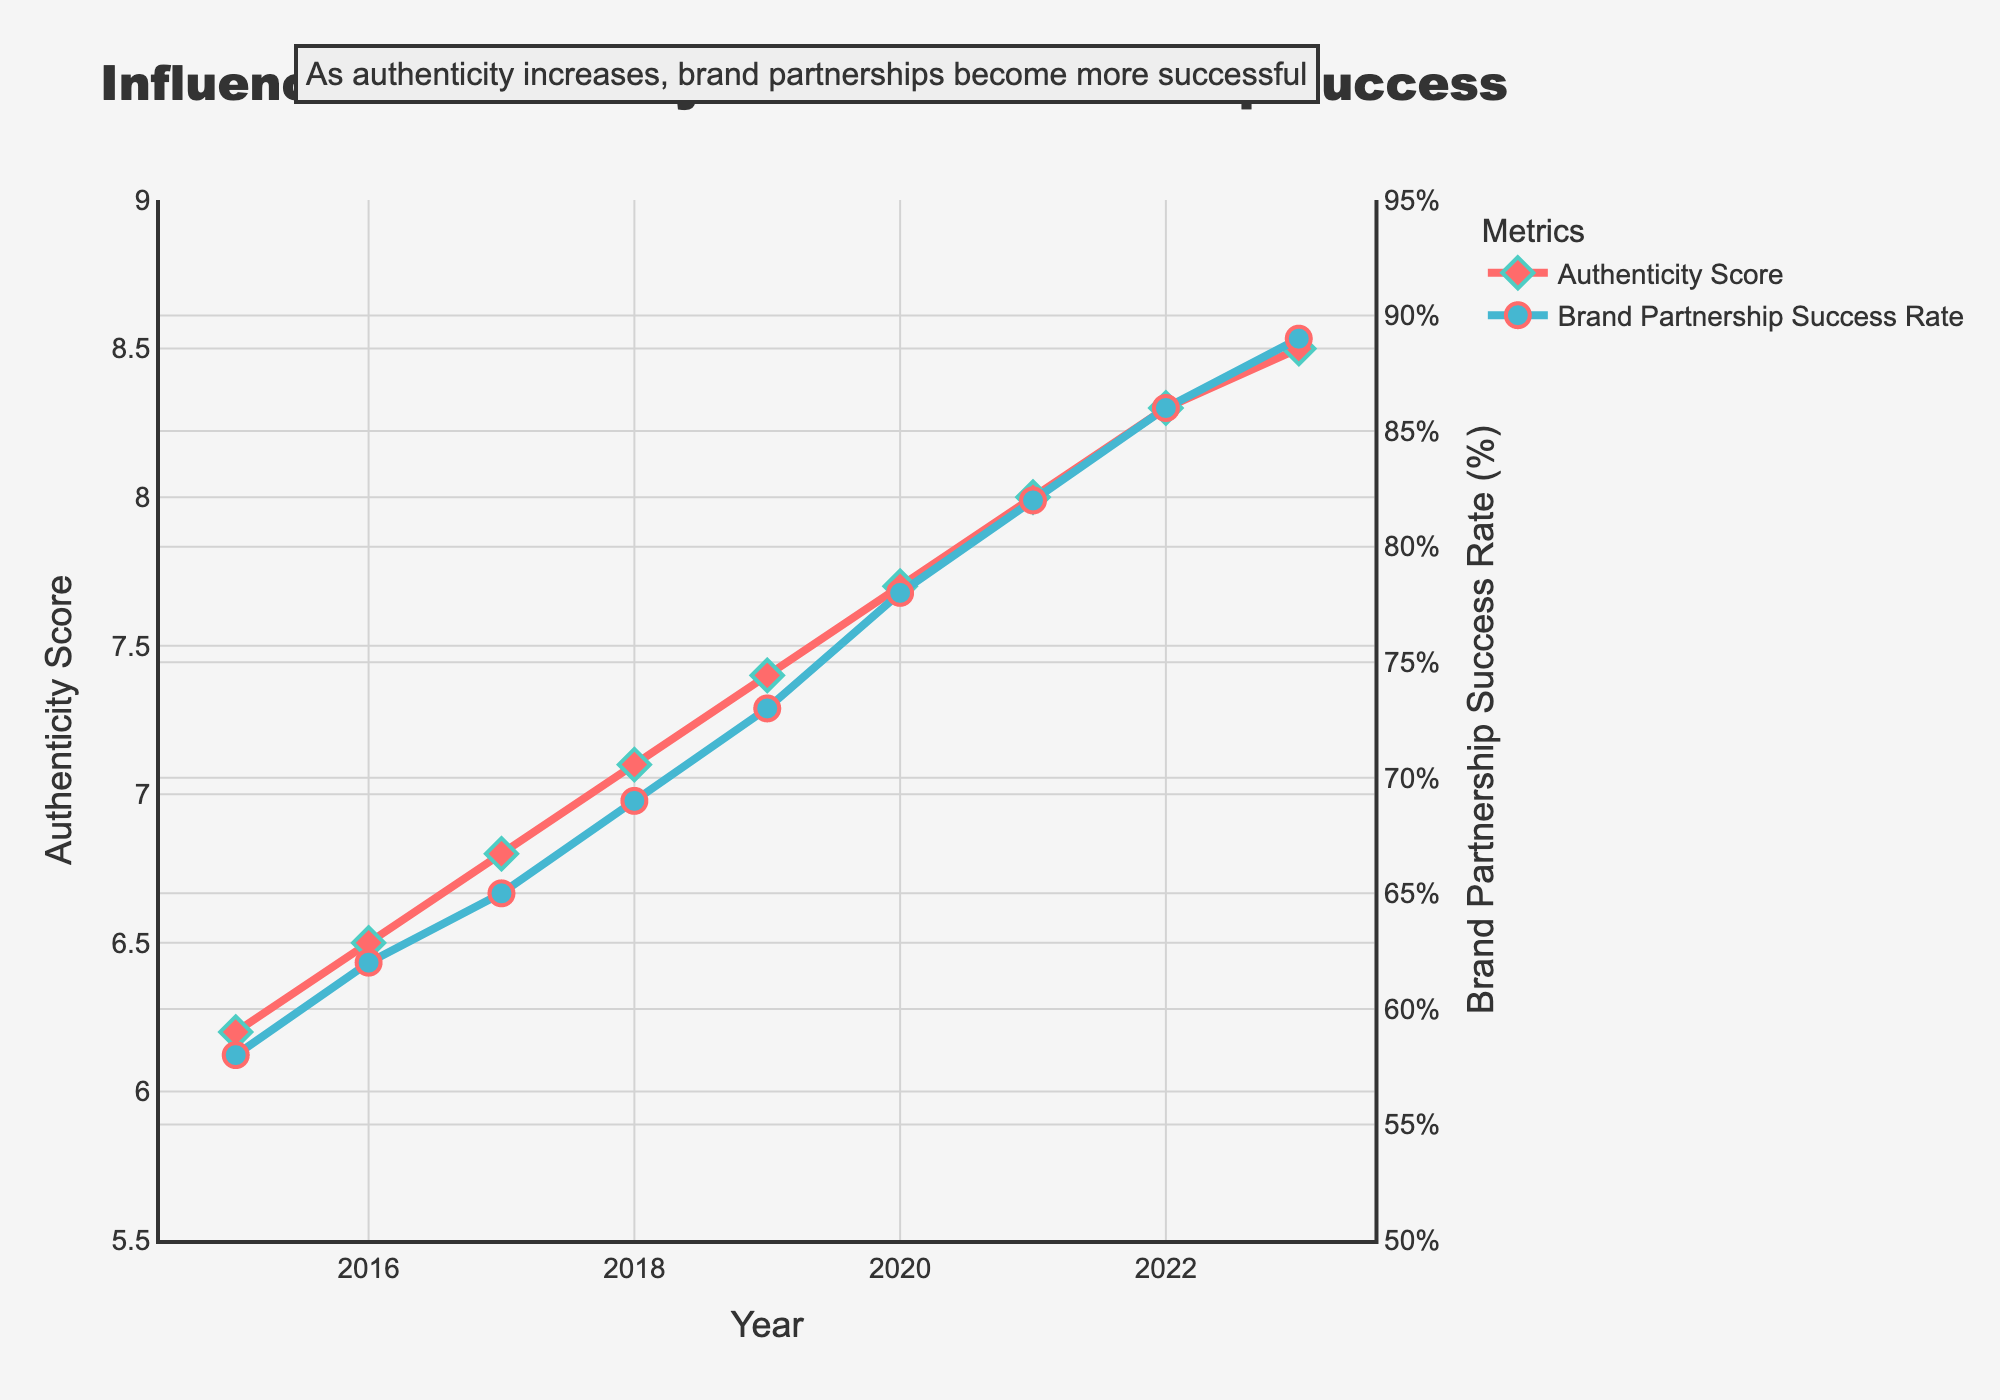What trend do you observe between the authenticity score and brand partnership success rate from 2015 to 2023? The line chart shows an upward trend, indicating that as the authenticity score increases, the brand partnership success rate also increases over time. This suggests a positive correlation between the two metrics.
Answer: They both increase How much did the authenticity score increase between 2015 and 2023? The authenticity score in 2015 was 6.2 and in 2023 it reached 8.5. To find the increase, subtract the initial score from the final score: 8.5 - 6.2 = 2.3.
Answer: 2.3 Which year saw the highest increase in brand partnership success rate and how much was that increase? To find this, we examine the change in success rates between consecutive years. From the data, the highest increase occurred between 2020 (78%) and 2021 (82%), which is an increase of 4%.
Answer: 2021, 4% In which year did the authenticity score surpass 8.0 for the first time? Look for the year when the authenticity score first exceeds 8.0. The data shows that in 2021, the score is 8.0, and in 2022 it is 8.3, indicating 2022 as the first year to surpass 8.0.
Answer: 2022 How many years did it take for the brand partnership success rate to increase from 58% to above 85%? The success rate was 58% in 2015 and exceeded 85% in 2022 (86%). Count the number of years from 2015 to 2022: 2022 - 2015 = 7 years.
Answer: 7 years Compare the authenticity scores for the years 2018 and 2022. Which year had a higher score and by how much? The authenticity score for 2018 is 7.1, and for 2022 it is 8.3. Subtract the 2018 score from the 2022 score: 8.3 - 7.1 = 1.2.
Answer: 2022, 1.2 What is the percentage difference in brand partnership success rates between the years 2016 and 2023? The success rate in 2016 was 62% and in 2023 it was 89%. Calculate the difference: 89% - 62% = 27%.
Answer: 27% Does the figure suggest a correlation between the authenticity score and brand partnership success rate? If so, what type of correlation? The figure shows that as the authenticity score increases, the brand partnership success rate also increases, indicating a positive correlation between the two variables.
Answer: Positive What is the average authenticity score from 2015 to 2023? Add up all the authenticity scores and divide by the number of years: (6.2 + 6.5 + 6.8 + 7.1 + 7.4 + 7.7 + 8.0 + 8.3 + 8.5) / 9 = 66.5 / 9 ≈ 7.39.
Answer: 7.39 How does the plot visually indicate the overall trend in both metrics from 2015 to 2023? The plot shows both lines with consistent upward slopes, diamond markers for authenticity scores, and circle markers for success rates. This visual representation indicates a steady increase over time for both metrics.
Answer: Upward slopes 